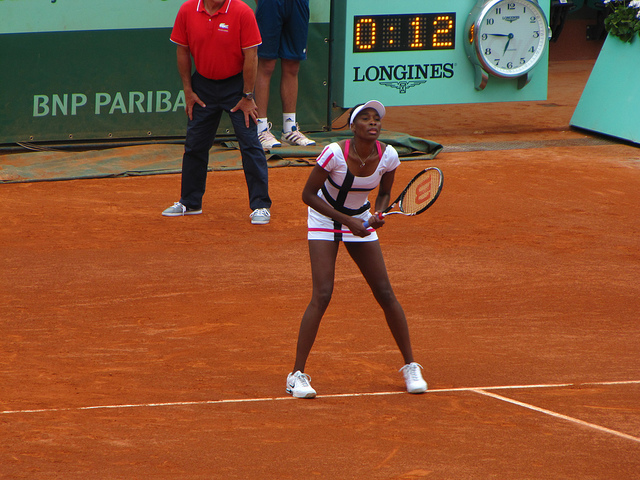<image>What is the score? The score is unknown. What is the score? The score is unknown or unavailable. It can be 0-1, 12-0, 0:12, 0 to 12, or 1-1. 